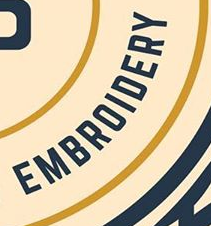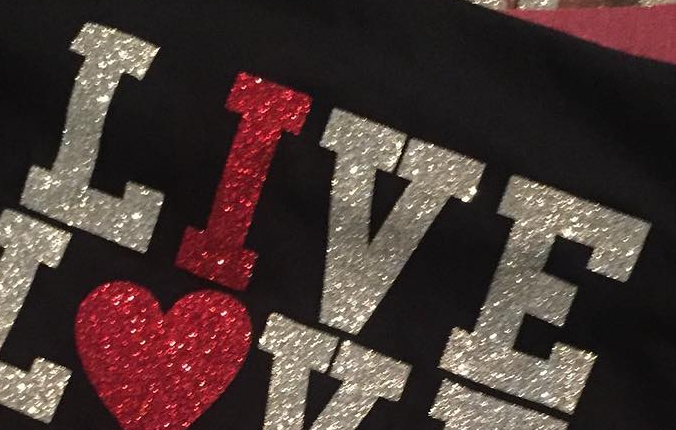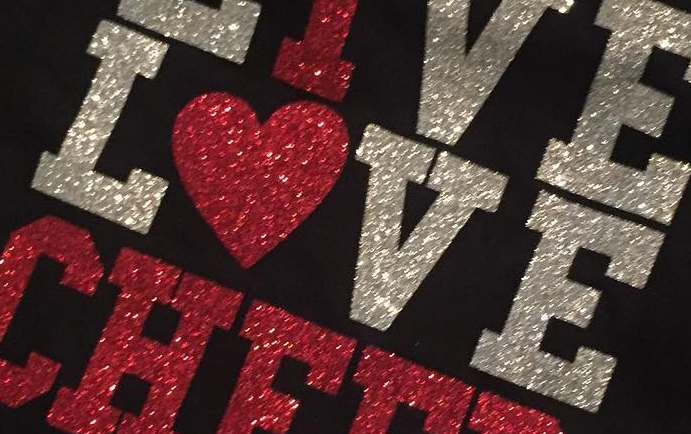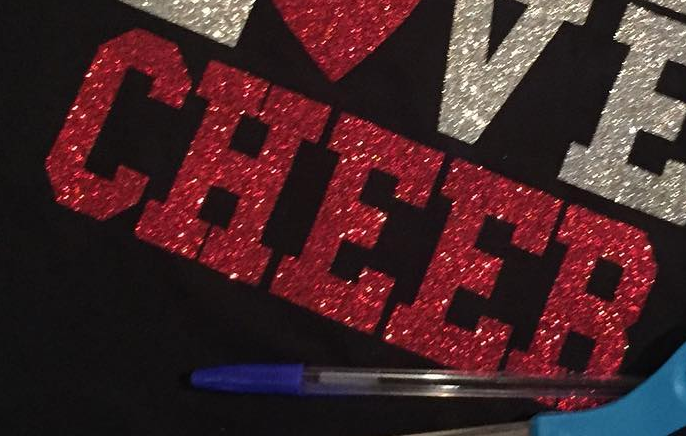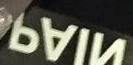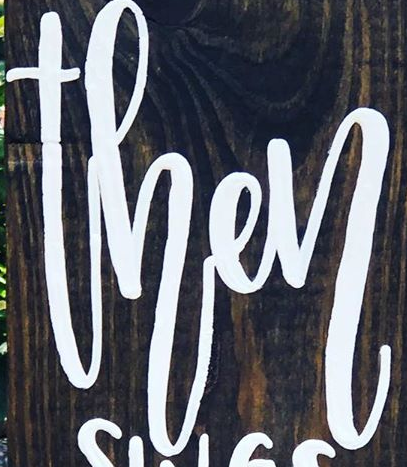Transcribe the words shown in these images in order, separated by a semicolon. EMBROIDERY; LIVE; LOVE; CHEER; NIAP; then 